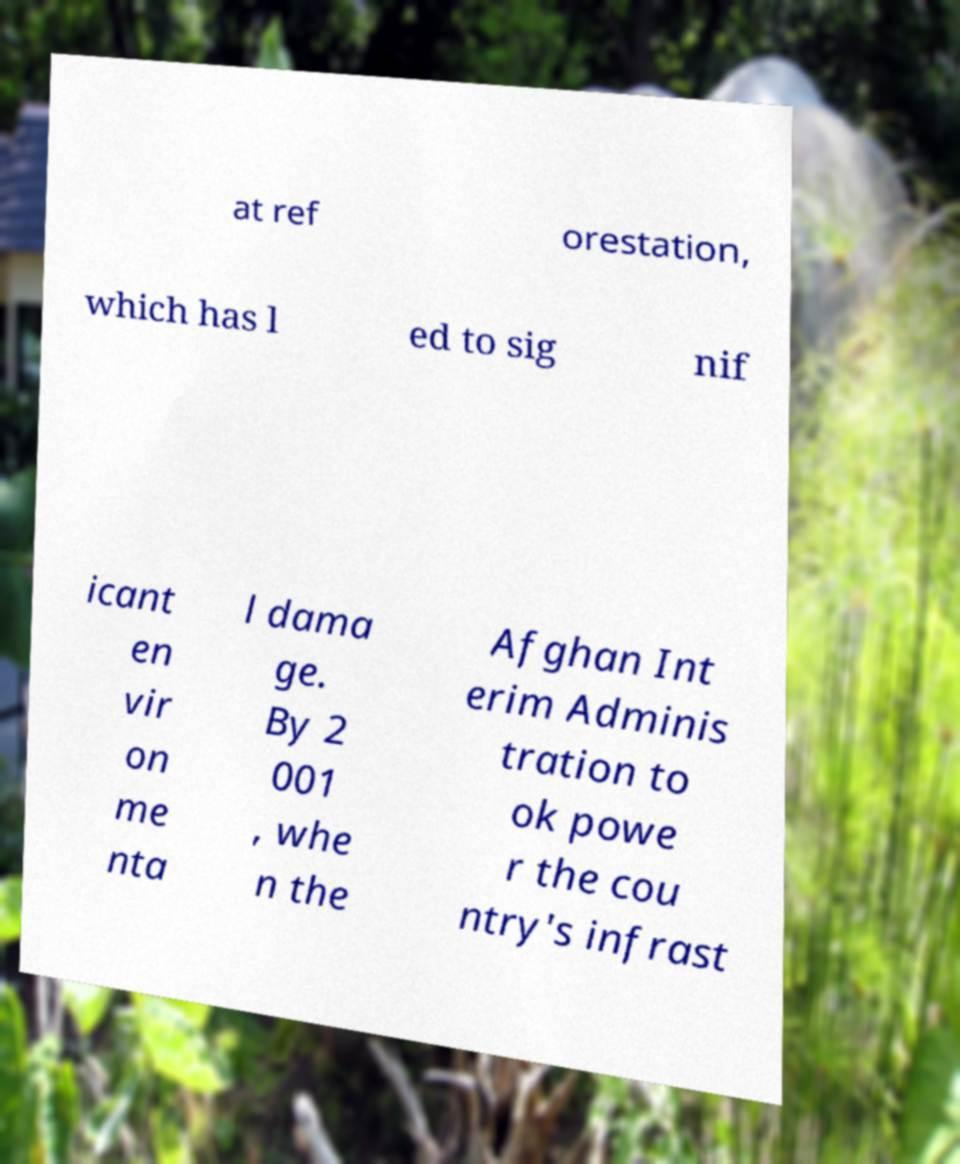Could you assist in decoding the text presented in this image and type it out clearly? at ref orestation, which has l ed to sig nif icant en vir on me nta l dama ge. By 2 001 , whe n the Afghan Int erim Adminis tration to ok powe r the cou ntry's infrast 